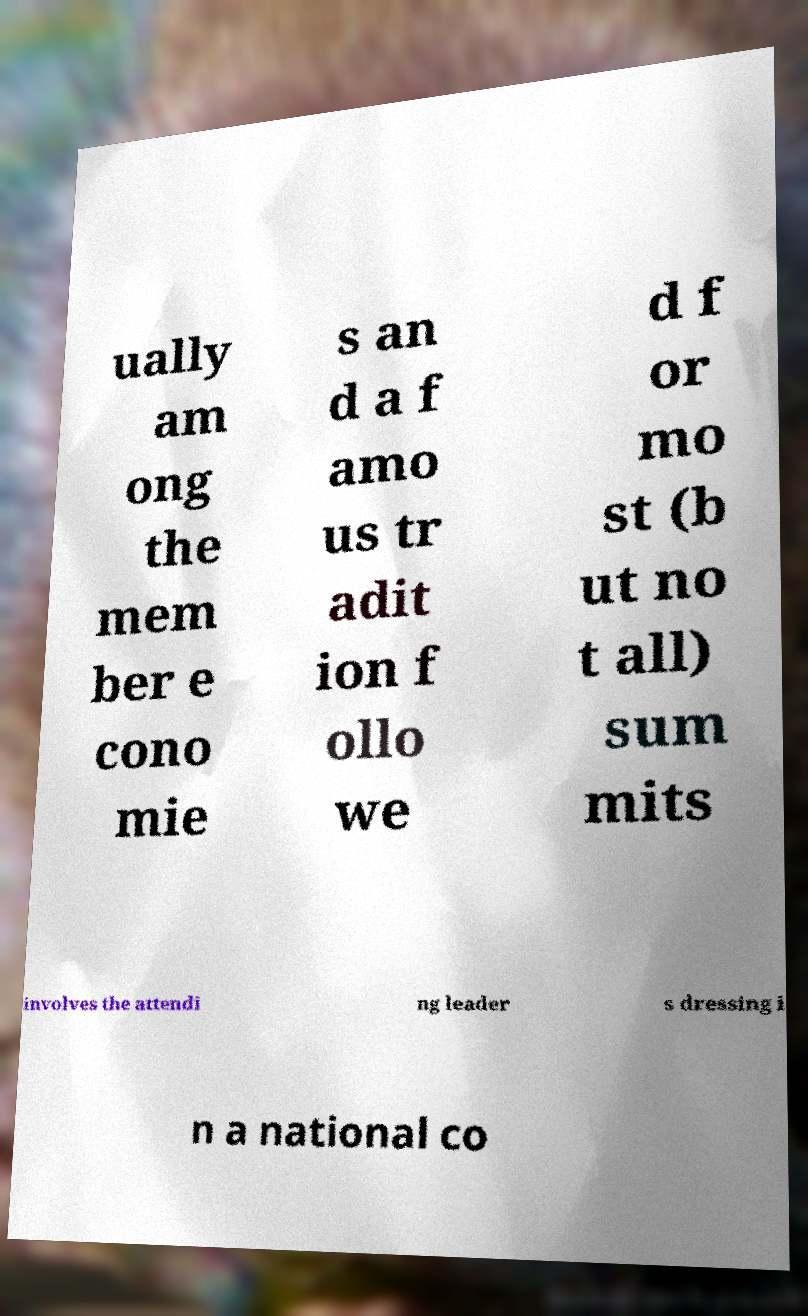Could you extract and type out the text from this image? ually am ong the mem ber e cono mie s an d a f amo us tr adit ion f ollo we d f or mo st (b ut no t all) sum mits involves the attendi ng leader s dressing i n a national co 